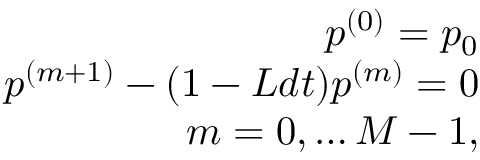Convert formula to latex. <formula><loc_0><loc_0><loc_500><loc_500>\begin{array} { r } { p ^ { ( 0 ) } = p _ { 0 } } \\ { p ^ { ( m + 1 ) } - ( 1 - L d t ) p ^ { ( m ) } = 0 } \\ { m = 0 , \dots M - 1 , } \end{array}</formula> 